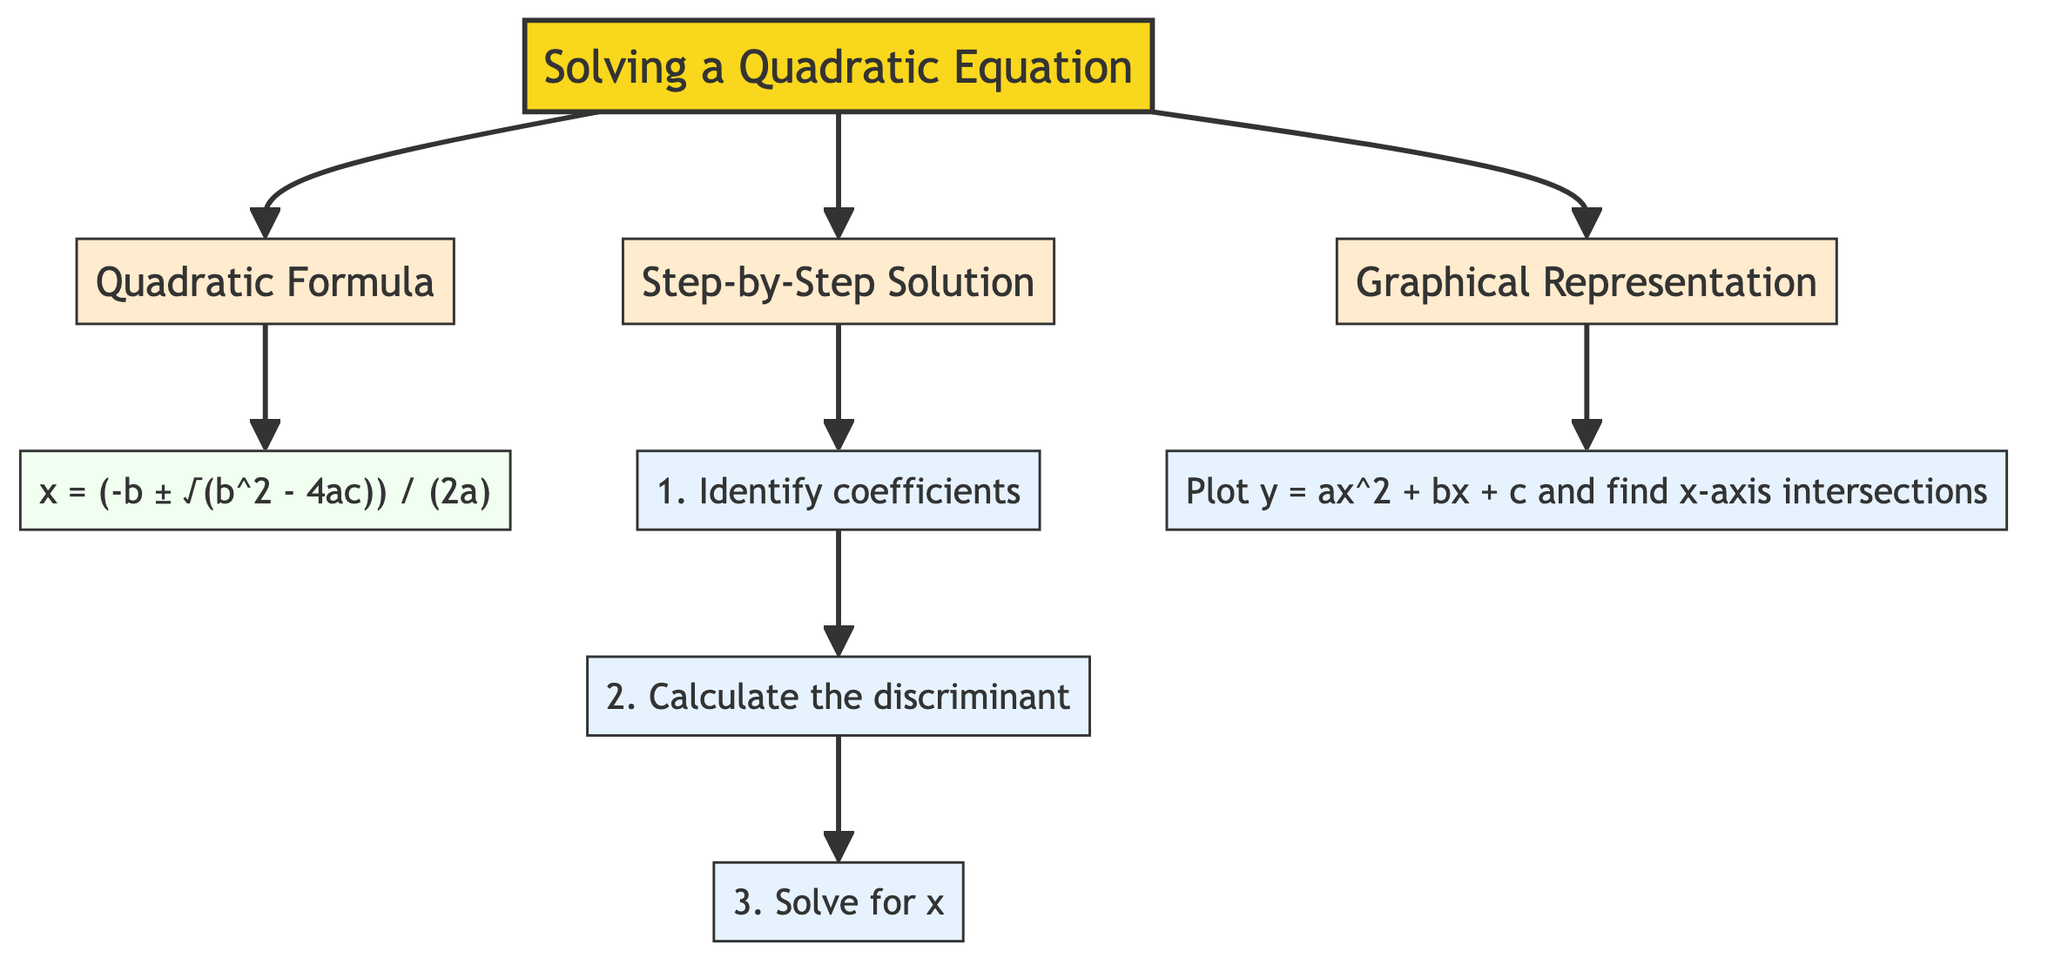What is the title of the diagram? The diagram clearly states the title at the beginning, which is "Solving a Quadratic Equation." This is the main topic being addressed.
Answer: Solving a Quadratic Equation How many steps are there in the step-by-step solution? There are three distinct steps listed in the diagram under the "Step-by-Step Solution" section. Counted visually from the diagram, they are Step1, Step2, and Step3.
Answer: 3 What does the quadratic formula look like? The quadratic formula is displayed under the "Quadratic Formula" section. It states: "x = (-b ± √(b^2 - 4ac)) / (2a)." This is crucial for solving quadratic equations.
Answer: x = (-b ± √(b^2 - 4ac)) / (2a) What do you do in Step 2 of the solution? In Step 2, the task is to "Calculate the discriminant." This step follows the identification of coefficients and is essential for determining the nature of the roots.
Answer: Calculate the discriminant What does the graphical representation involve? The graphical representation section describes the action to "Plot y = ax^2 + bx + c and find x-axis intersections." This involves visualizing the quadratic equation and locating the solutions graphically.
Answer: Plot y = ax^2 + bx + c and find x-axis intersections What is the purpose of the quadratic formula? The purpose is to provide a mathematical expression that allows for finding the values of x that satisfy the quadratic equation. This is emphasized through its placement in the diagram as a central component.
Answer: To find x values Which step comes after identifying coefficients? After identifying coefficients in Step 1, the next action is in Step 2, which involves calculating the discriminant. This sequencing shows the progression of solving the quadratic equation.
Answer: Calculate the discriminant What color is used for the title class? The title class is represented with the color fill of #f9d71c in the diagram. This is a specific choice made to make the title stand out.
Answer: #f9d71c What are the key components of the quadratic formula? The key components identified in the formula include variables a, b, and c, as well as the discriminant portion √(b^2 - 4ac) and the division by (2a). These elements are essential for solving the quadratic equations.
Answer: Variables a, b, c, and discriminant 